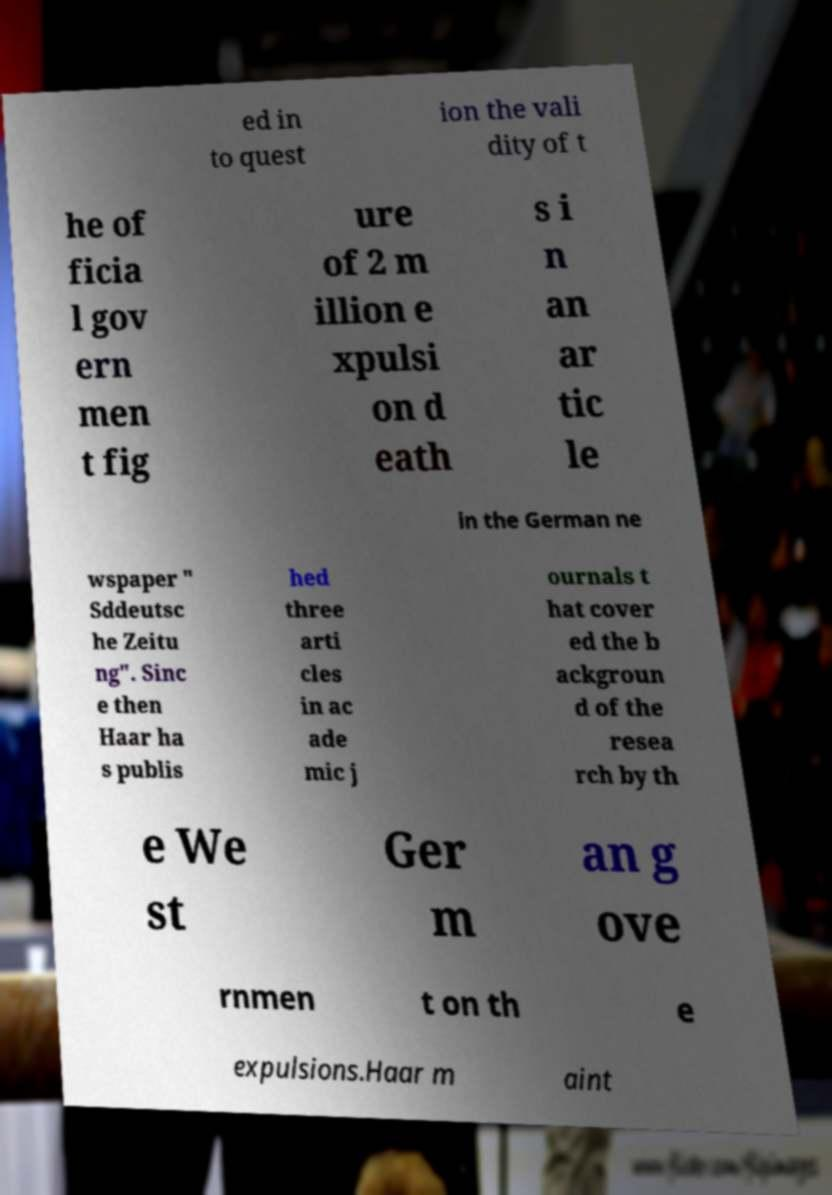Can you read and provide the text displayed in the image?This photo seems to have some interesting text. Can you extract and type it out for me? ed in to quest ion the vali dity of t he of ficia l gov ern men t fig ure of 2 m illion e xpulsi on d eath s i n an ar tic le in the German ne wspaper " Sddeutsc he Zeitu ng". Sinc e then Haar ha s publis hed three arti cles in ac ade mic j ournals t hat cover ed the b ackgroun d of the resea rch by th e We st Ger m an g ove rnmen t on th e expulsions.Haar m aint 